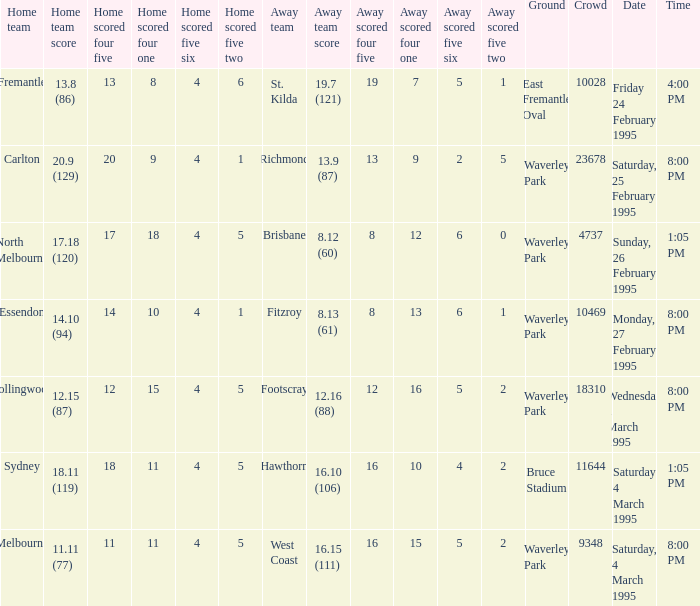Name the ground for essendon Waverley Park. 